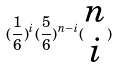Convert formula to latex. <formula><loc_0><loc_0><loc_500><loc_500>( \frac { 1 } { 6 } ) ^ { i } ( \frac { 5 } { 6 } ) ^ { n - i } ( \begin{matrix} n \\ i \end{matrix} )</formula> 